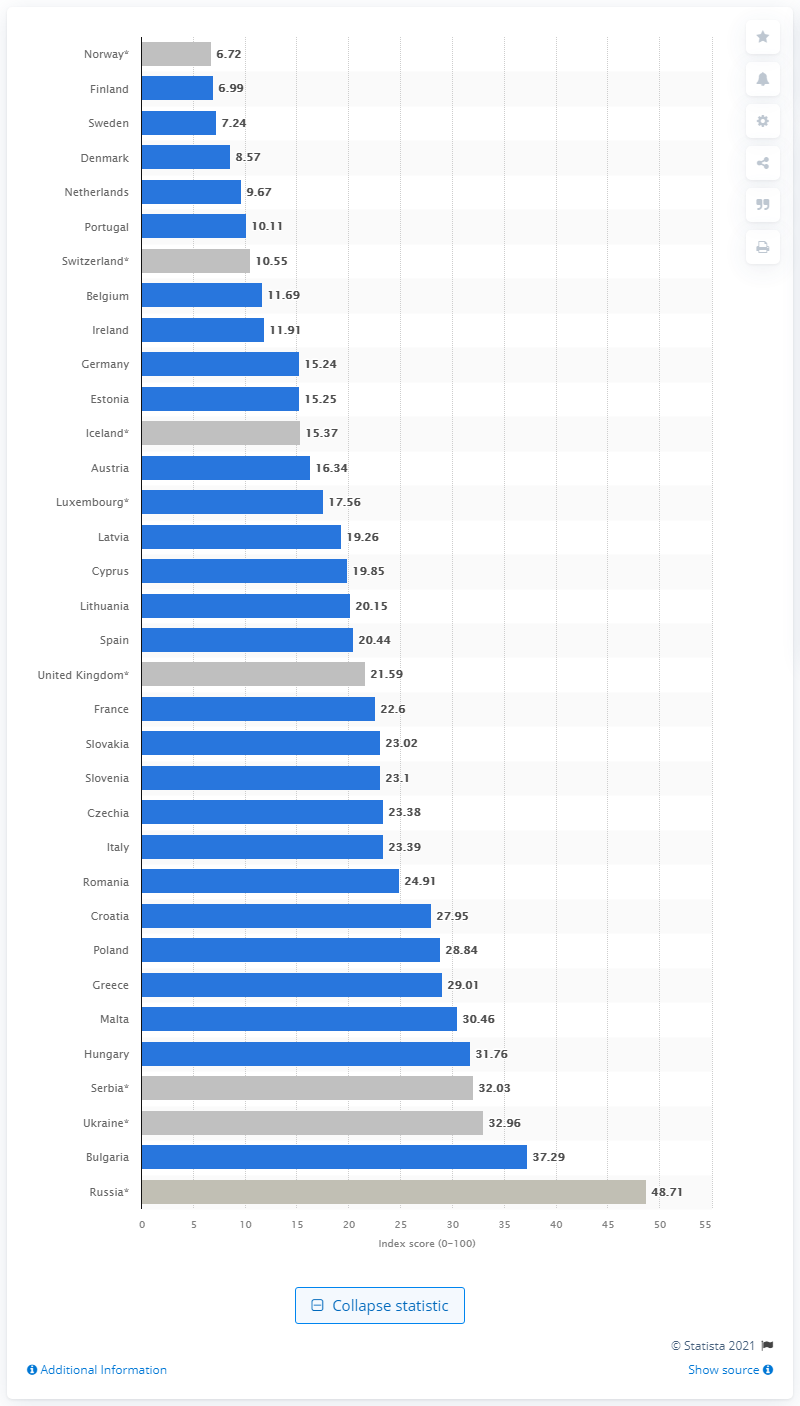Specify some key components in this picture. Norway's press freedom index score in 2021 was 6.72, which marks a decline from the previous year and reflects ongoing challenges to freedom of the press in the country. 